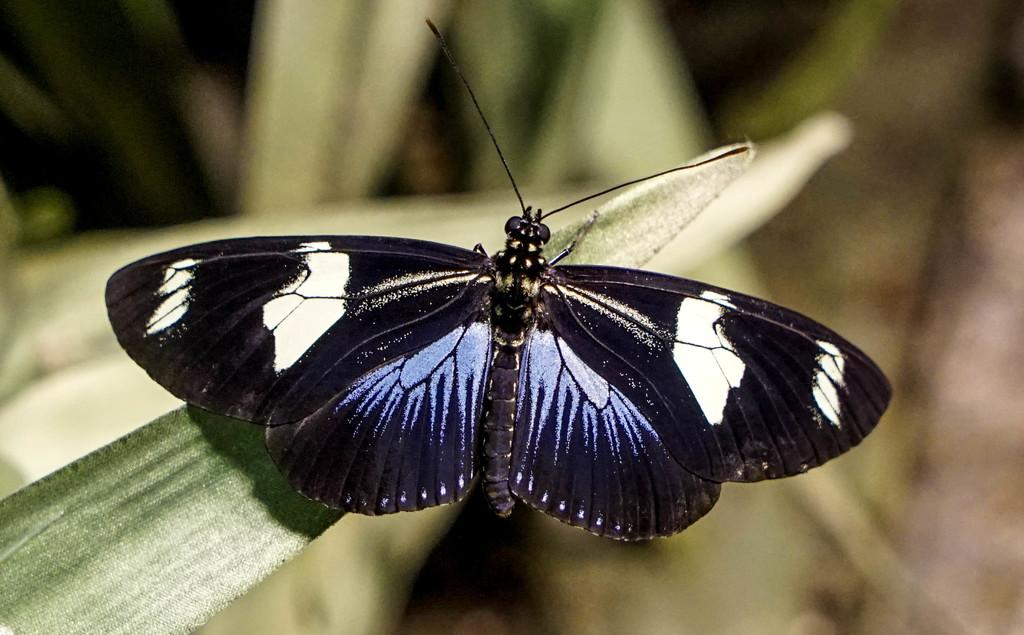What is the main subject of the image? There is a butterfly in the image. Where is the butterfly located? The butterfly is on a leaf. What is the name of the liquid that the butterfly is drinking from the bucket in the image? There is no bucket or liquid present in the image; it only features a butterfly on a leaf. 